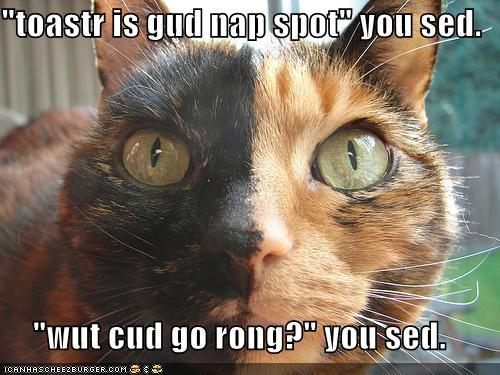What can you say about the cat's nose, and what makes it unusual? The cat's nose is pink and black, with the two colors split in the middle. This unusual coloring makes it stand out on the cat's face. What is the primary object in the image and what are its main features? The primary object is a cat's face, which is orange, white, and black with green eyes, white whiskers, a pink and black nose, and pointy ears. Comment on the background setting of the image. The background features a field of green grass, green trees, and a brown fence. It suggests that the cat is outdoors, with nature visible behind it. What is the color of the cat's eyes, and is there anything interesting about them? The cat's eyes are green, with a large black slit on the eyeball and a black speck in the corner of one eye. They are also particolored and yellow in some areas. How many ears does the cat have, and what is their shape? The cat has two pointy ears, which are directed upwards and form a triangular shape. What is the overall sentiment of the image, and why? The image has a playful and amusing sentiment, mainly due to the unique coloring of the cat's face, the misspelled meme-style writing, and the interesting combination of features presented. Identify the key elements of the cat's face in this picture. The cat's face has green eyes, white whiskers, pointy ears, and a pink and black nose. Half of the face is black, while the other half has orange and white fur. Can you describe the surroundings of the cat in the image? There is a green grass field, trees, and a brown fence in the background. The picture also contains some writing, which is misspelled and white in color. What is written on the image and how is it spelled? There is a meme-style writing on the image that is misspelled, as if the cat wrote it. The letters are white in color, and the writing is present both above the cat's head and across the bottom. Point out the noticeable patterns and colors on the cat's face. The cat's face displays a Janus coloring, with one half being black and the other half being a mix of orange, white, and brown. The cat also has green eyes and white whiskers. Are the cat's eyes completely black? The instruction is misleading because the captions "cat's left eye" and "cat's right eye" describe the eyes as having green and yellow colors, not being completely black. Is the grass behind the cat blue? The instruction is misleading because the grass is described as green in the captions "grass can be seen in the background" and "the grass is green." Are the cat's whiskers red in color? The instruction is misleading because the captions describe the whiskers as white: "long white whiskers coming off the face," "the cat has white whiskers," and "white cat whiskers." Do the trees in the picture have pink leaves? The instruction is misleading because the captions describe the trees as green: "trees can be seen in the background" and "the trees are green." Is there a dog in the background? The instruction is misleading because there are no captions mentioning the presence of a dog. Instead, the captions mention a cat: "calico cat's head," "a cat is in the picture." Is the cat's face entirely orange? The instruction is misleading because the cat has not only an orange face, but is also black and white, as mentioned in the captions "black and orange cat face," "the cat is orange white and black," and "half of the face is black." 